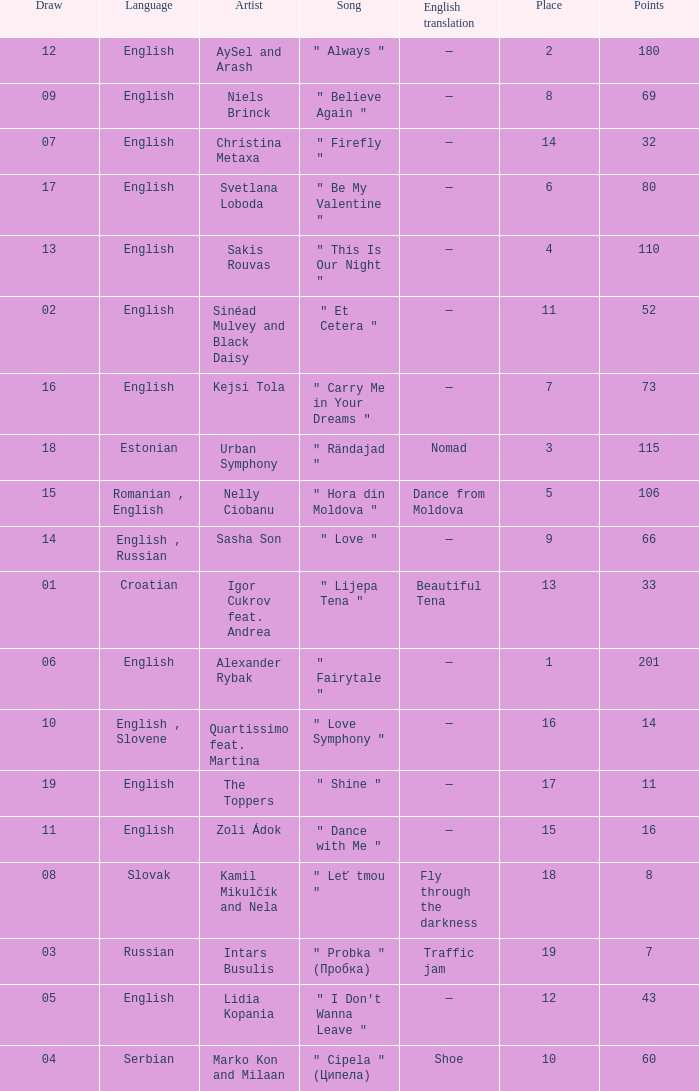What is the english translation when the language is english, draw is smaller than 16, and the artist is aysel and arash? —. 